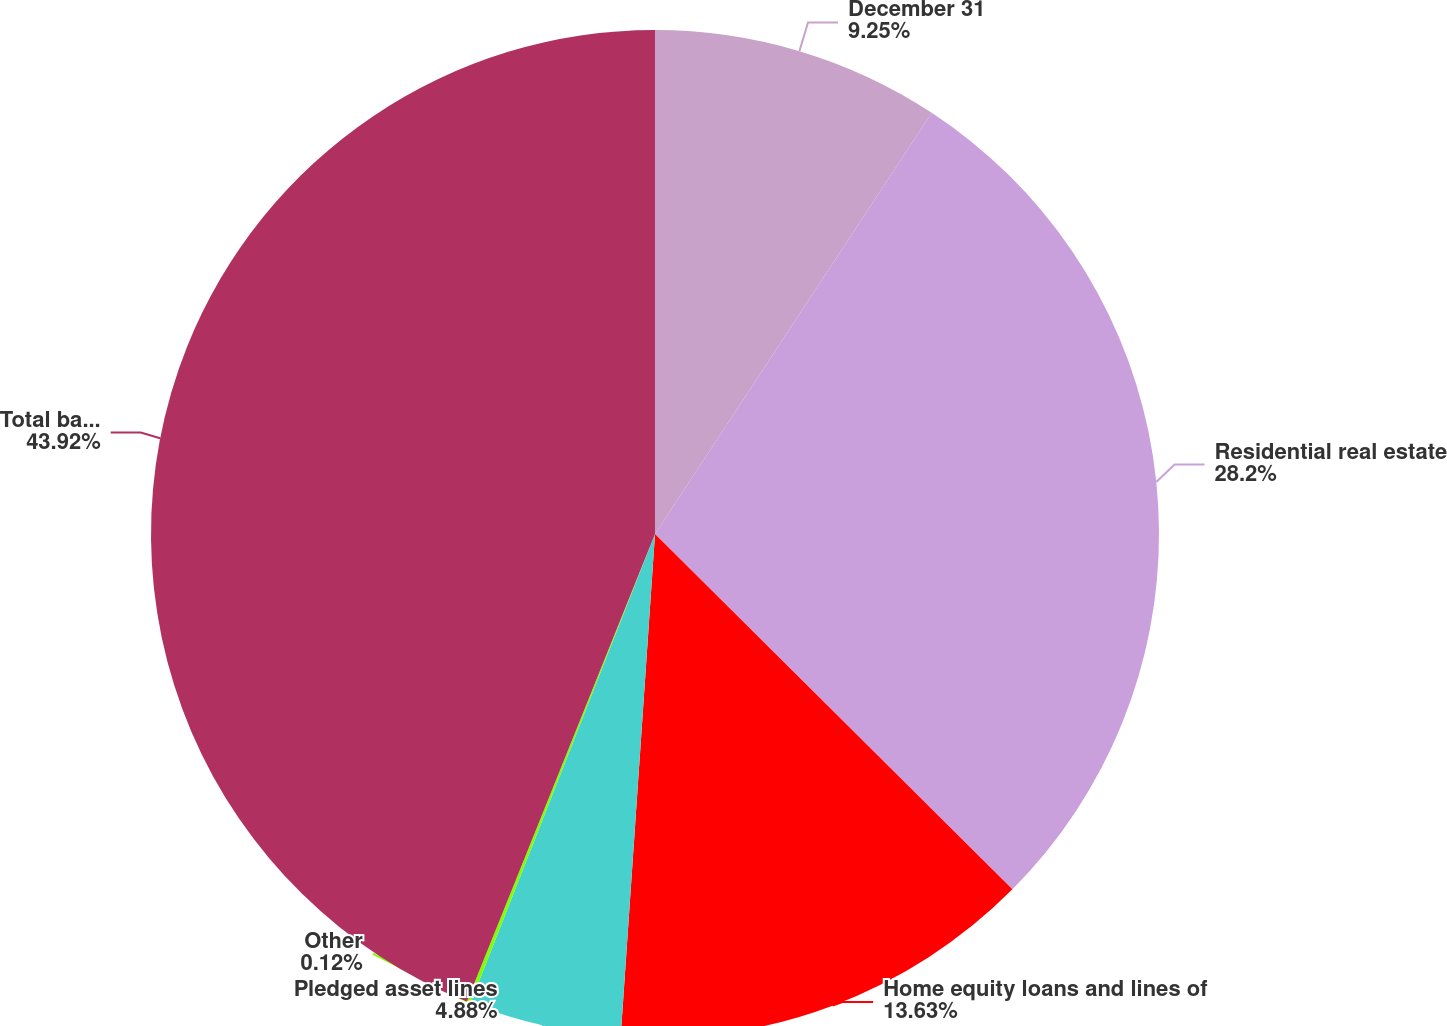Convert chart to OTSL. <chart><loc_0><loc_0><loc_500><loc_500><pie_chart><fcel>December 31<fcel>Residential real estate<fcel>Home equity loans and lines of<fcel>Pledged asset lines<fcel>Other<fcel>Total bank loans<nl><fcel>9.25%<fcel>28.2%<fcel>13.63%<fcel>4.88%<fcel>0.12%<fcel>43.91%<nl></chart> 